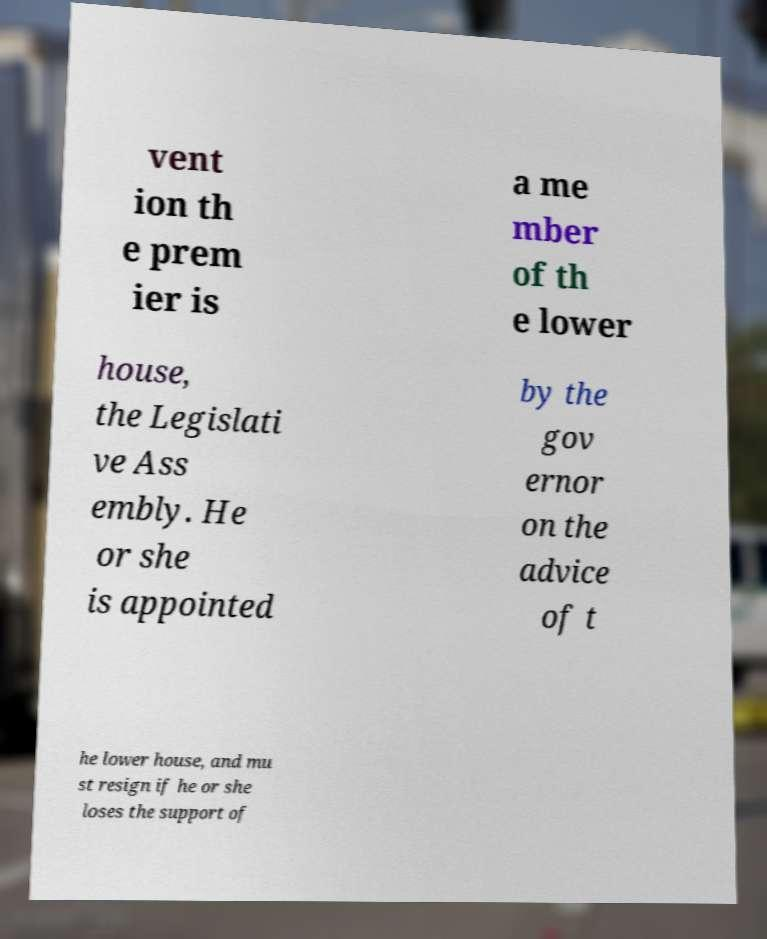Could you extract and type out the text from this image? vent ion th e prem ier is a me mber of th e lower house, the Legislati ve Ass embly. He or she is appointed by the gov ernor on the advice of t he lower house, and mu st resign if he or she loses the support of 